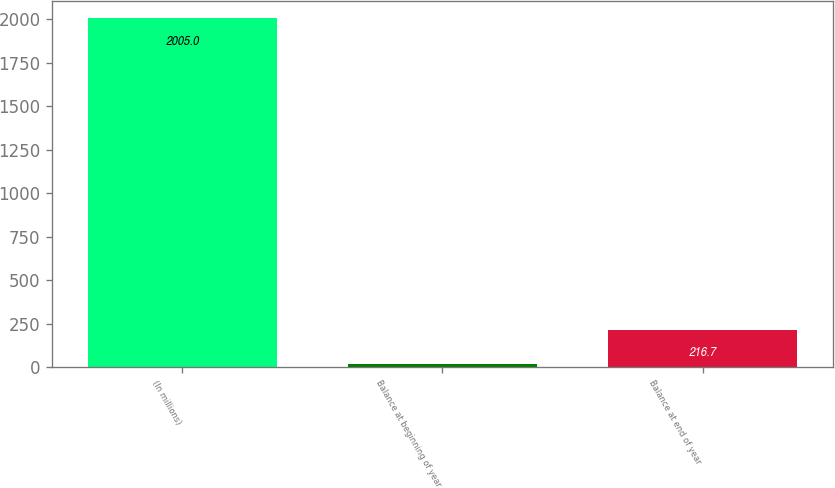<chart> <loc_0><loc_0><loc_500><loc_500><bar_chart><fcel>(In millions)<fcel>Balance at beginning of year<fcel>Balance at end of year<nl><fcel>2005<fcel>18<fcel>216.7<nl></chart> 